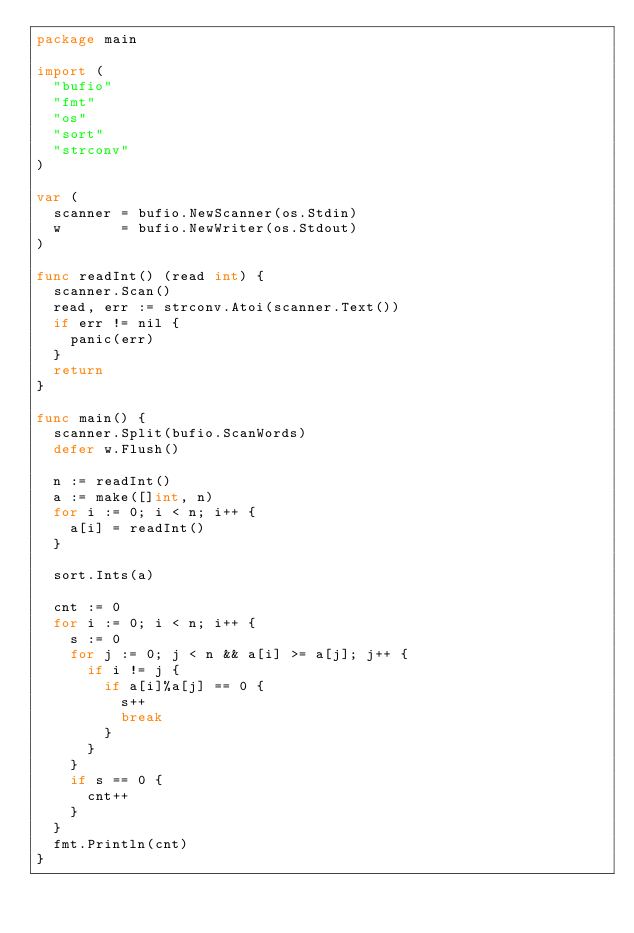<code> <loc_0><loc_0><loc_500><loc_500><_Go_>package main

import (
	"bufio"
	"fmt"
	"os"
	"sort"
	"strconv"
)

var (
	scanner = bufio.NewScanner(os.Stdin)
	w       = bufio.NewWriter(os.Stdout)
)

func readInt() (read int) {
	scanner.Scan()
	read, err := strconv.Atoi(scanner.Text())
	if err != nil {
		panic(err)
	}
	return
}

func main() {
	scanner.Split(bufio.ScanWords)
	defer w.Flush()

	n := readInt()
	a := make([]int, n)
	for i := 0; i < n; i++ {
		a[i] = readInt()
	}

	sort.Ints(a)

	cnt := 0
	for i := 0; i < n; i++ {
		s := 0
		for j := 0; j < n && a[i] >= a[j]; j++ {
			if i != j {
				if a[i]%a[j] == 0 {
					s++
					break
				}
			}
		}
		if s == 0 {
			cnt++
		}
	}
	fmt.Println(cnt)
}
</code> 